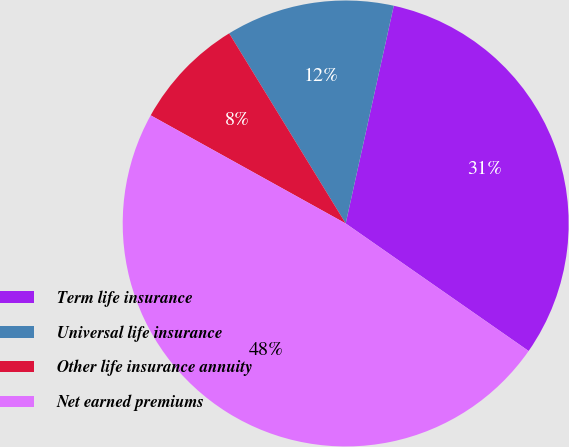<chart> <loc_0><loc_0><loc_500><loc_500><pie_chart><fcel>Term life insurance<fcel>Universal life insurance<fcel>Other life insurance annuity<fcel>Net earned premiums<nl><fcel>31.23%<fcel>12.21%<fcel>8.19%<fcel>48.37%<nl></chart> 